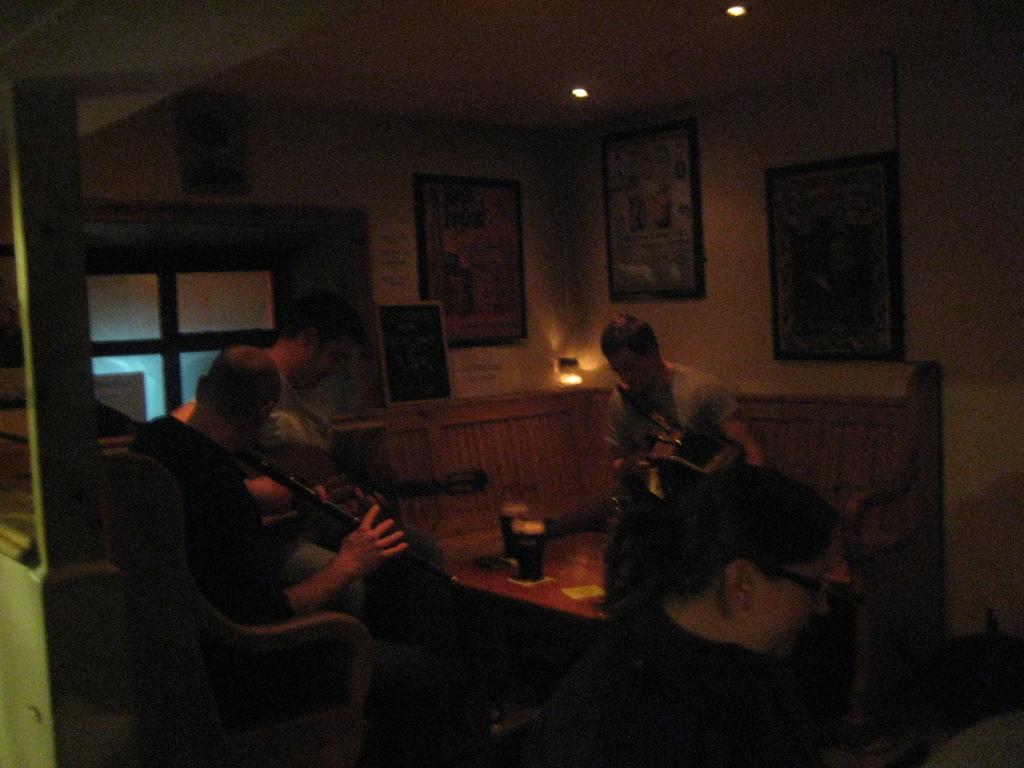Describe this image in one or two sentences. These persons are sitting on a chair. On this table there are glasses. On wall there are different type of pictures. Far there is a light. 